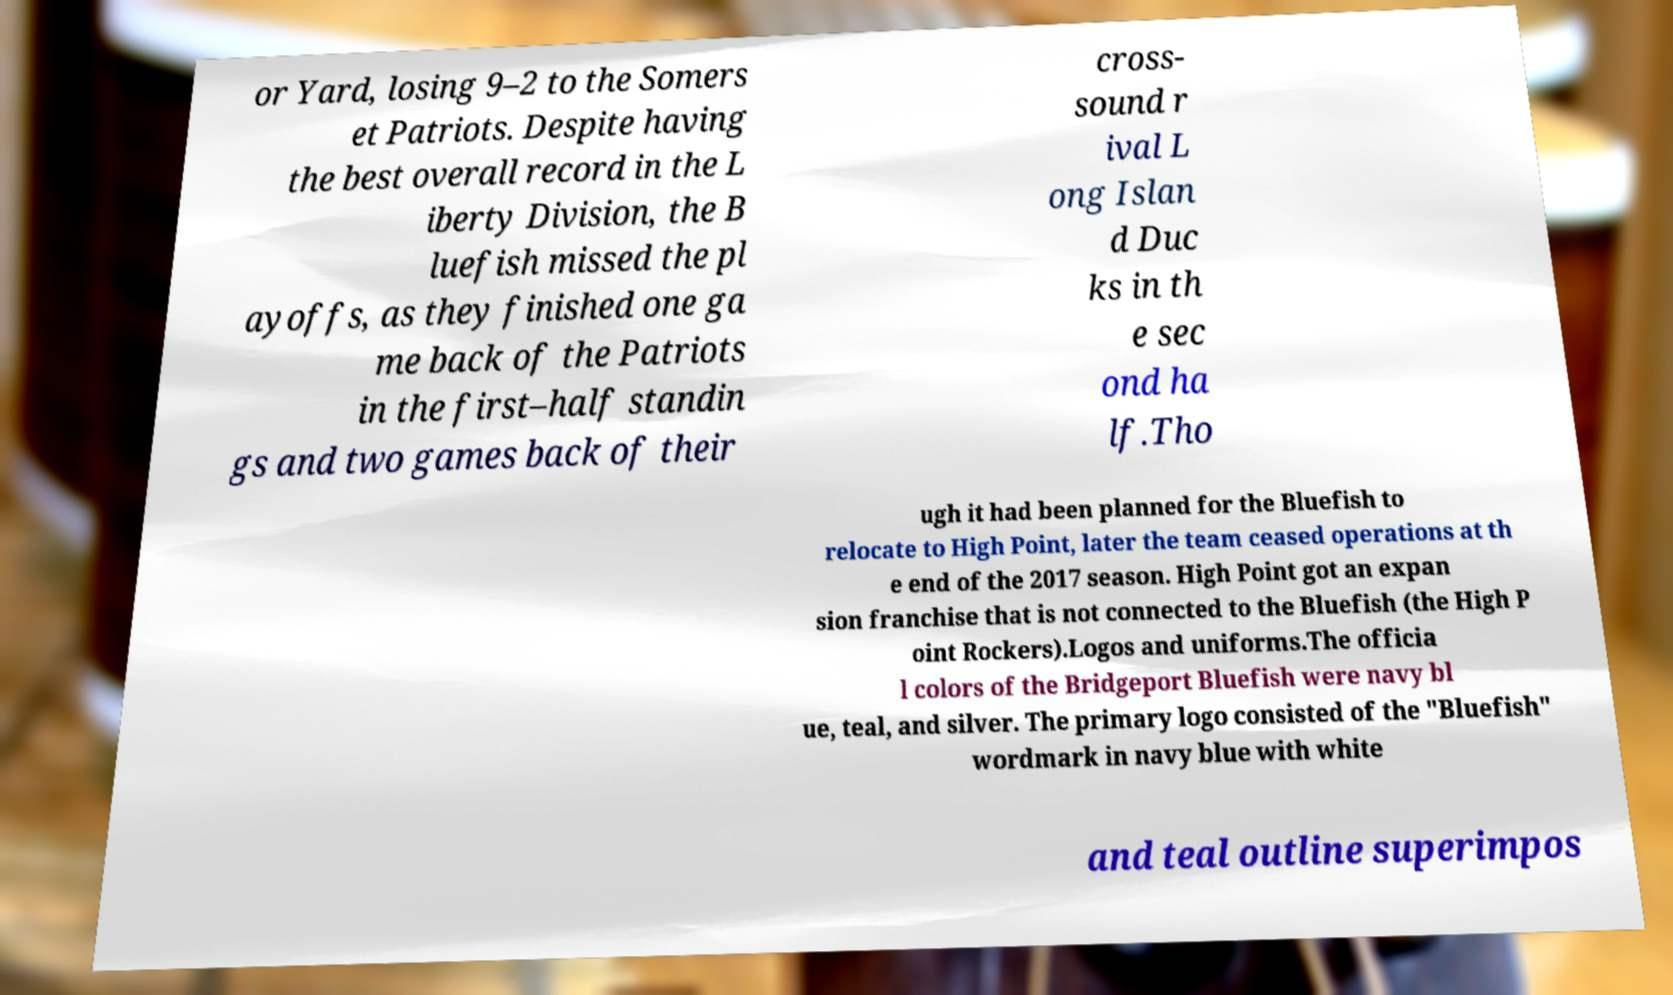For documentation purposes, I need the text within this image transcribed. Could you provide that? or Yard, losing 9–2 to the Somers et Patriots. Despite having the best overall record in the L iberty Division, the B luefish missed the pl ayoffs, as they finished one ga me back of the Patriots in the first–half standin gs and two games back of their cross- sound r ival L ong Islan d Duc ks in th e sec ond ha lf.Tho ugh it had been planned for the Bluefish to relocate to High Point, later the team ceased operations at th e end of the 2017 season. High Point got an expan sion franchise that is not connected to the Bluefish (the High P oint Rockers).Logos and uniforms.The officia l colors of the Bridgeport Bluefish were navy bl ue, teal, and silver. The primary logo consisted of the "Bluefish" wordmark in navy blue with white and teal outline superimpos 